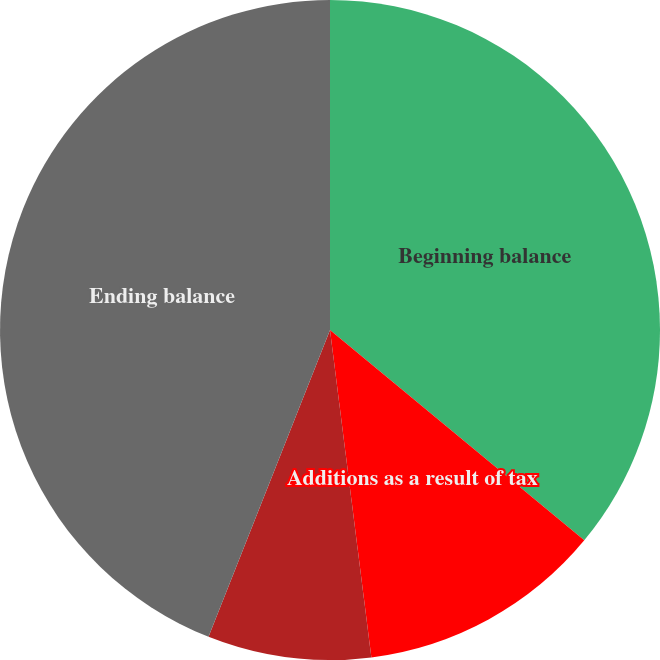Convert chart. <chart><loc_0><loc_0><loc_500><loc_500><pie_chart><fcel>Beginning balance<fcel>Additions as a result of tax<fcel>Reductions due to the<fcel>Ending balance<nl><fcel>36.0%<fcel>12.0%<fcel>8.0%<fcel>44.0%<nl></chart> 